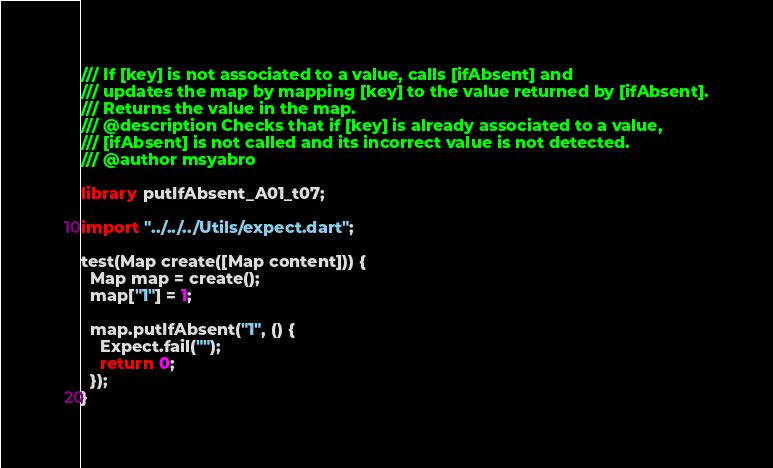<code> <loc_0><loc_0><loc_500><loc_500><_Dart_>/// If [key] is not associated to a value, calls [ifAbsent] and
/// updates the map by mapping [key] to the value returned by [ifAbsent].
/// Returns the value in the map.
/// @description Checks that if [key] is already associated to a value,
/// [ifAbsent] is not called and its incorrect value is not detected.
/// @author msyabro

library putIfAbsent_A01_t07;

import "../../../Utils/expect.dart";

test(Map create([Map content])) {
  Map map = create();
  map["1"] = 1;

  map.putIfAbsent("1", () {
    Expect.fail("");
    return 0;
  });
}
</code> 